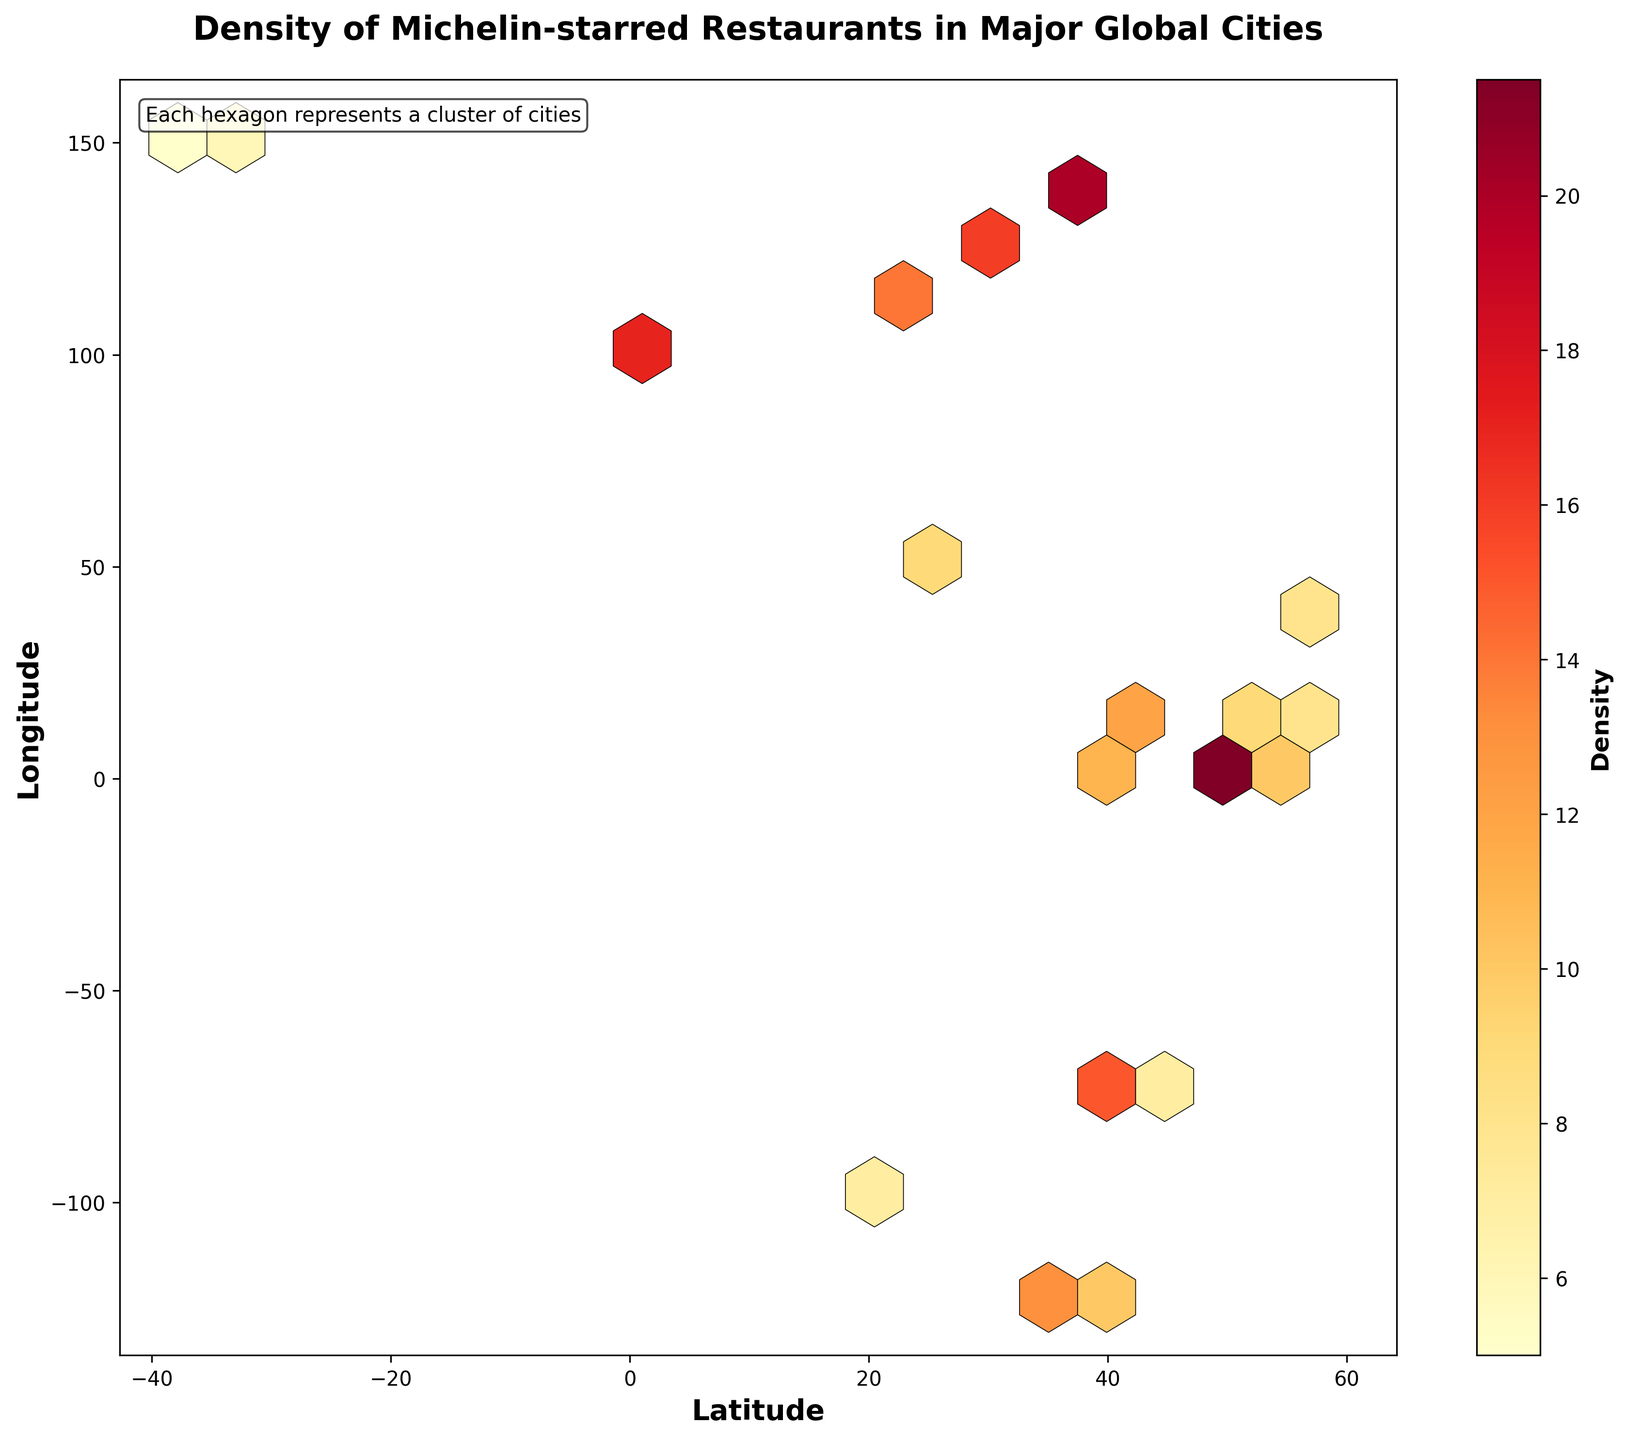Which city has the highest density of Michelin-starred restaurants? By observing the color intensity and referring to the density color scale, the city with the highest density is the one represented by the darkest shade. In this case, the hexagon around Paris (latitude 48.8566, longitude 2.3522) is the darkest, indicating the highest density value of 25.
Answer: Paris What does the color bar represent in this plot? The color bar on the right side of the plot represents the density of Michelin-starred restaurants. The shade gradient from lighter to darker indicates increasing density, with specific values associated with different color intensities.
Answer: Density Can you identify a region with low densities of Michelin-starred restaurants? By looking at regions with lighter shades within the hexagons, one can identify areas with lower densities. For instance, the hexagon around Melbourne (latitude -37.8136, longitude 144.9631) has one of the lightest shades, indicating a density value of 5.
Answer: Melbourne Which two cities have density values closest to each other, and what are those values? Observing the color shades and the density values, one can identify Berlin (latitude 52.5200, longitude 13.4050) and Dubai (latitude 25.2048, longitude 55.2708) as having close densities (9 each).
Answer: Berlin and Dubai, 9 Compare the density of Michelin-starred restaurants between Tokyo and New York City. Tokyo's hexagon (latitude 35.6762, longitude 139.6503) has a darker shade indicating a density value of 20, whereas New York City's hexagon (latitude 40.7128, longitude -74.0060) has a slightly lighter shade, indicating a density value of 15. Thus, Tokyo has a higher density compared to New York City.
Answer: Tokyo > New York City What can be inferred about Michelin-starred restaurant density around latitude 50-60 degrees and longitudes 10-20 degrees? This region roughly includes cities like Berlin (density 9) and Stockholm (latitude 59.3293, longitude 18.0686, density 8). Their values, represented by their color shades, indicate moderate densities but not extreme high values compared to Paris or Tokyo.
Answer: Moderate density Count the number of distinct density levels represented in the plot. By examining the color bar and the different shades on the hexagons, one can count distinct colors. The distinct density values in the data are 5, 6, 7, 8, 9, 10, 11, 12, 13, 14, 15, 16, 17, 18, 20, and 25, making 16 different levels.
Answer: 16 Describe the overall pattern in the distribution of Michelin-starred restaurant densities in major cities. Most Michelin-starred restaurants are concentrated in a few cities represented by darker shades (high densities) such as Paris, Tokyo, London, and Singapore. Lesser densities (lighter shades) are seen in cities like Melbourne and Mexico City. This suggests a high concentration in prominent gastronomic capitals with fewer distributions in other global cities.
Answer: High concentration in a few cities 